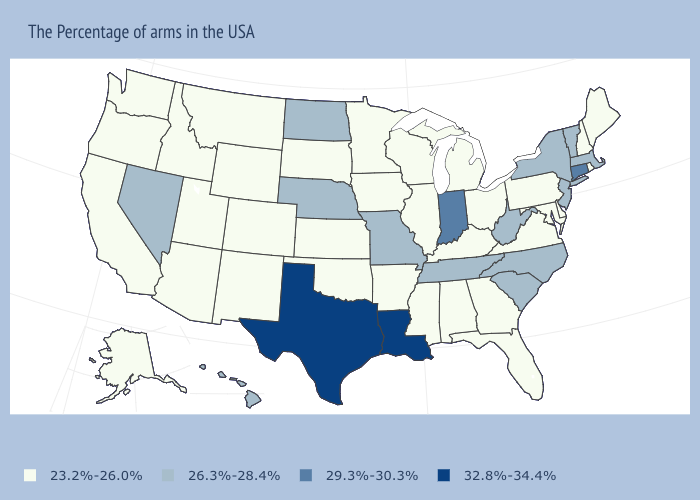Name the states that have a value in the range 32.8%-34.4%?
Concise answer only. Louisiana, Texas. What is the highest value in the USA?
Keep it brief. 32.8%-34.4%. Does North Carolina have a lower value than Kansas?
Be succinct. No. What is the value of Kentucky?
Concise answer only. 23.2%-26.0%. What is the value of California?
Be succinct. 23.2%-26.0%. What is the lowest value in the West?
Give a very brief answer. 23.2%-26.0%. Name the states that have a value in the range 26.3%-28.4%?
Quick response, please. Massachusetts, Vermont, New York, New Jersey, North Carolina, South Carolina, West Virginia, Tennessee, Missouri, Nebraska, North Dakota, Nevada, Hawaii. Does Alaska have the lowest value in the West?
Concise answer only. Yes. Does the map have missing data?
Be succinct. No. What is the value of Pennsylvania?
Write a very short answer. 23.2%-26.0%. Which states hav the highest value in the South?
Write a very short answer. Louisiana, Texas. Which states hav the highest value in the MidWest?
Keep it brief. Indiana. Does Montana have the same value as Alabama?
Short answer required. Yes. Name the states that have a value in the range 23.2%-26.0%?
Concise answer only. Maine, Rhode Island, New Hampshire, Delaware, Maryland, Pennsylvania, Virginia, Ohio, Florida, Georgia, Michigan, Kentucky, Alabama, Wisconsin, Illinois, Mississippi, Arkansas, Minnesota, Iowa, Kansas, Oklahoma, South Dakota, Wyoming, Colorado, New Mexico, Utah, Montana, Arizona, Idaho, California, Washington, Oregon, Alaska. What is the value of Wisconsin?
Quick response, please. 23.2%-26.0%. 